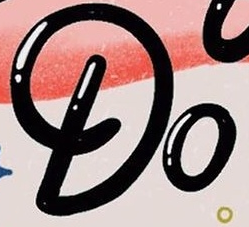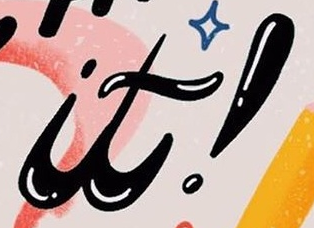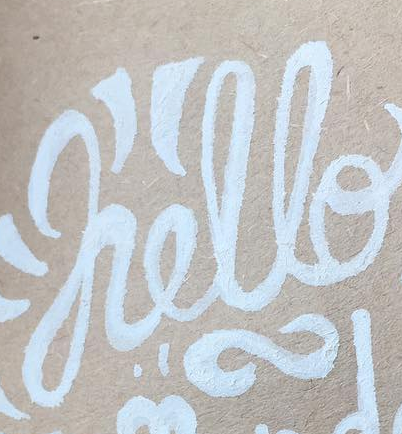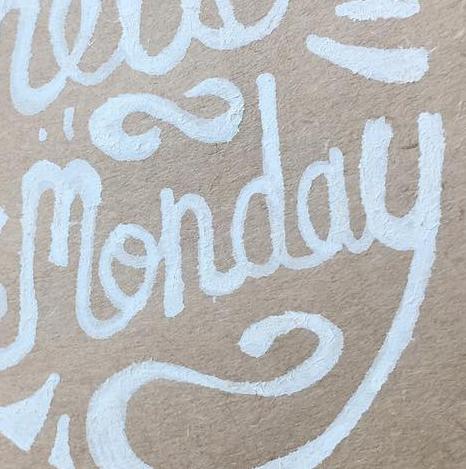Read the text content from these images in order, separated by a semicolon. Do; it!; hello; monday 